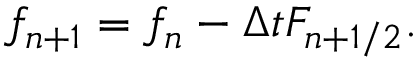<formula> <loc_0><loc_0><loc_500><loc_500>f _ { n + 1 } = f _ { n } - \Delta t F _ { n + 1 / 2 } .</formula> 